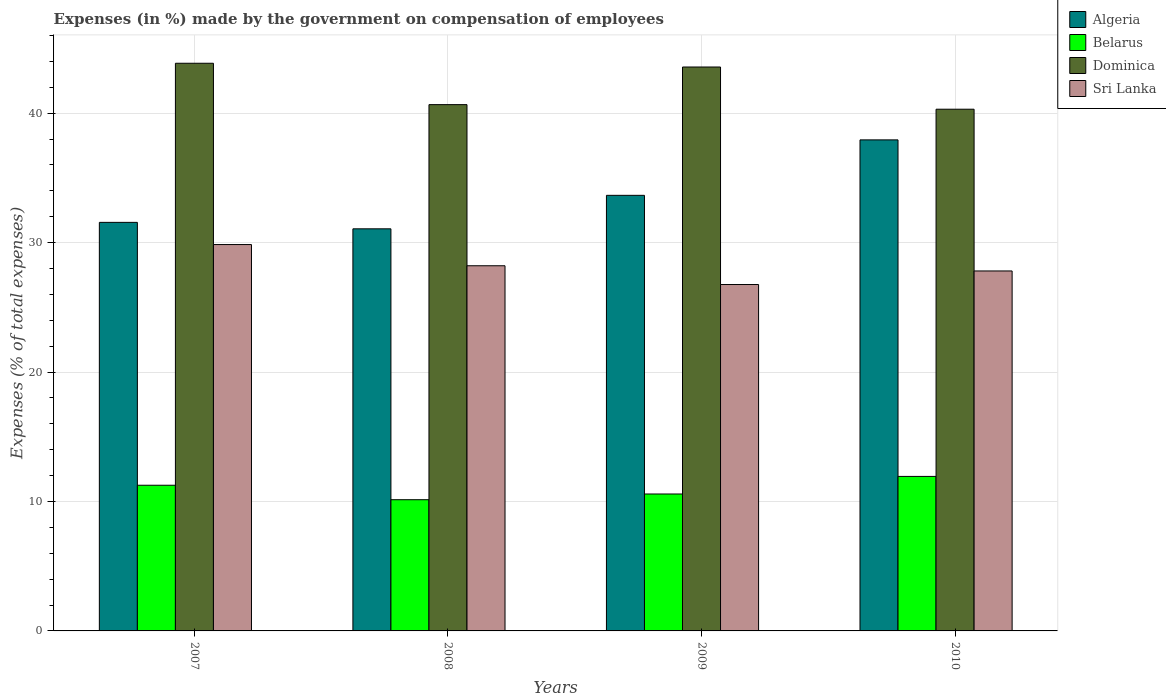How many different coloured bars are there?
Ensure brevity in your answer.  4. Are the number of bars per tick equal to the number of legend labels?
Provide a short and direct response. Yes. Are the number of bars on each tick of the X-axis equal?
Ensure brevity in your answer.  Yes. What is the percentage of expenses made by the government on compensation of employees in Sri Lanka in 2010?
Your response must be concise. 27.81. Across all years, what is the maximum percentage of expenses made by the government on compensation of employees in Dominica?
Your response must be concise. 43.86. Across all years, what is the minimum percentage of expenses made by the government on compensation of employees in Dominica?
Offer a terse response. 40.31. In which year was the percentage of expenses made by the government on compensation of employees in Dominica maximum?
Keep it short and to the point. 2007. In which year was the percentage of expenses made by the government on compensation of employees in Sri Lanka minimum?
Provide a succinct answer. 2009. What is the total percentage of expenses made by the government on compensation of employees in Belarus in the graph?
Provide a succinct answer. 43.91. What is the difference between the percentage of expenses made by the government on compensation of employees in Dominica in 2008 and that in 2009?
Offer a very short reply. -2.91. What is the difference between the percentage of expenses made by the government on compensation of employees in Belarus in 2010 and the percentage of expenses made by the government on compensation of employees in Dominica in 2009?
Offer a terse response. -31.63. What is the average percentage of expenses made by the government on compensation of employees in Dominica per year?
Provide a short and direct response. 42.1. In the year 2009, what is the difference between the percentage of expenses made by the government on compensation of employees in Belarus and percentage of expenses made by the government on compensation of employees in Dominica?
Provide a succinct answer. -32.99. What is the ratio of the percentage of expenses made by the government on compensation of employees in Sri Lanka in 2008 to that in 2010?
Make the answer very short. 1.01. What is the difference between the highest and the second highest percentage of expenses made by the government on compensation of employees in Algeria?
Your response must be concise. 4.28. What is the difference between the highest and the lowest percentage of expenses made by the government on compensation of employees in Sri Lanka?
Provide a short and direct response. 3.09. In how many years, is the percentage of expenses made by the government on compensation of employees in Algeria greater than the average percentage of expenses made by the government on compensation of employees in Algeria taken over all years?
Offer a very short reply. 2. Is it the case that in every year, the sum of the percentage of expenses made by the government on compensation of employees in Dominica and percentage of expenses made by the government on compensation of employees in Algeria is greater than the sum of percentage of expenses made by the government on compensation of employees in Belarus and percentage of expenses made by the government on compensation of employees in Sri Lanka?
Your answer should be compact. No. What does the 4th bar from the left in 2009 represents?
Make the answer very short. Sri Lanka. What does the 4th bar from the right in 2009 represents?
Keep it short and to the point. Algeria. Is it the case that in every year, the sum of the percentage of expenses made by the government on compensation of employees in Belarus and percentage of expenses made by the government on compensation of employees in Sri Lanka is greater than the percentage of expenses made by the government on compensation of employees in Dominica?
Ensure brevity in your answer.  No. How many bars are there?
Provide a short and direct response. 16. Are the values on the major ticks of Y-axis written in scientific E-notation?
Provide a short and direct response. No. Does the graph contain grids?
Ensure brevity in your answer.  Yes. How many legend labels are there?
Offer a terse response. 4. What is the title of the graph?
Keep it short and to the point. Expenses (in %) made by the government on compensation of employees. Does "United Arab Emirates" appear as one of the legend labels in the graph?
Offer a very short reply. No. What is the label or title of the X-axis?
Offer a terse response. Years. What is the label or title of the Y-axis?
Provide a short and direct response. Expenses (% of total expenses). What is the Expenses (% of total expenses) in Algeria in 2007?
Provide a succinct answer. 31.57. What is the Expenses (% of total expenses) in Belarus in 2007?
Keep it short and to the point. 11.26. What is the Expenses (% of total expenses) of Dominica in 2007?
Offer a terse response. 43.86. What is the Expenses (% of total expenses) in Sri Lanka in 2007?
Keep it short and to the point. 29.85. What is the Expenses (% of total expenses) in Algeria in 2008?
Offer a terse response. 31.07. What is the Expenses (% of total expenses) of Belarus in 2008?
Give a very brief answer. 10.14. What is the Expenses (% of total expenses) of Dominica in 2008?
Ensure brevity in your answer.  40.66. What is the Expenses (% of total expenses) of Sri Lanka in 2008?
Keep it short and to the point. 28.21. What is the Expenses (% of total expenses) in Algeria in 2009?
Your answer should be very brief. 33.66. What is the Expenses (% of total expenses) in Belarus in 2009?
Provide a short and direct response. 10.58. What is the Expenses (% of total expenses) of Dominica in 2009?
Make the answer very short. 43.57. What is the Expenses (% of total expenses) in Sri Lanka in 2009?
Your answer should be very brief. 26.76. What is the Expenses (% of total expenses) in Algeria in 2010?
Make the answer very short. 37.94. What is the Expenses (% of total expenses) in Belarus in 2010?
Your answer should be very brief. 11.94. What is the Expenses (% of total expenses) in Dominica in 2010?
Provide a succinct answer. 40.31. What is the Expenses (% of total expenses) of Sri Lanka in 2010?
Give a very brief answer. 27.81. Across all years, what is the maximum Expenses (% of total expenses) of Algeria?
Offer a very short reply. 37.94. Across all years, what is the maximum Expenses (% of total expenses) of Belarus?
Give a very brief answer. 11.94. Across all years, what is the maximum Expenses (% of total expenses) in Dominica?
Provide a succinct answer. 43.86. Across all years, what is the maximum Expenses (% of total expenses) in Sri Lanka?
Offer a terse response. 29.85. Across all years, what is the minimum Expenses (% of total expenses) in Algeria?
Offer a very short reply. 31.07. Across all years, what is the minimum Expenses (% of total expenses) of Belarus?
Make the answer very short. 10.14. Across all years, what is the minimum Expenses (% of total expenses) of Dominica?
Provide a short and direct response. 40.31. Across all years, what is the minimum Expenses (% of total expenses) in Sri Lanka?
Ensure brevity in your answer.  26.76. What is the total Expenses (% of total expenses) in Algeria in the graph?
Offer a very short reply. 134.23. What is the total Expenses (% of total expenses) in Belarus in the graph?
Your answer should be compact. 43.91. What is the total Expenses (% of total expenses) in Dominica in the graph?
Offer a terse response. 168.4. What is the total Expenses (% of total expenses) in Sri Lanka in the graph?
Offer a terse response. 112.64. What is the difference between the Expenses (% of total expenses) in Algeria in 2007 and that in 2008?
Your answer should be compact. 0.5. What is the difference between the Expenses (% of total expenses) in Belarus in 2007 and that in 2008?
Your answer should be very brief. 1.12. What is the difference between the Expenses (% of total expenses) in Dominica in 2007 and that in 2008?
Give a very brief answer. 3.2. What is the difference between the Expenses (% of total expenses) in Sri Lanka in 2007 and that in 2008?
Provide a succinct answer. 1.64. What is the difference between the Expenses (% of total expenses) of Algeria in 2007 and that in 2009?
Provide a succinct answer. -2.09. What is the difference between the Expenses (% of total expenses) of Belarus in 2007 and that in 2009?
Provide a short and direct response. 0.68. What is the difference between the Expenses (% of total expenses) in Dominica in 2007 and that in 2009?
Your response must be concise. 0.29. What is the difference between the Expenses (% of total expenses) of Sri Lanka in 2007 and that in 2009?
Offer a terse response. 3.09. What is the difference between the Expenses (% of total expenses) in Algeria in 2007 and that in 2010?
Offer a very short reply. -6.37. What is the difference between the Expenses (% of total expenses) of Belarus in 2007 and that in 2010?
Your answer should be very brief. -0.68. What is the difference between the Expenses (% of total expenses) in Dominica in 2007 and that in 2010?
Ensure brevity in your answer.  3.55. What is the difference between the Expenses (% of total expenses) in Sri Lanka in 2007 and that in 2010?
Offer a very short reply. 2.04. What is the difference between the Expenses (% of total expenses) of Algeria in 2008 and that in 2009?
Offer a terse response. -2.59. What is the difference between the Expenses (% of total expenses) of Belarus in 2008 and that in 2009?
Provide a succinct answer. -0.44. What is the difference between the Expenses (% of total expenses) of Dominica in 2008 and that in 2009?
Offer a very short reply. -2.91. What is the difference between the Expenses (% of total expenses) of Sri Lanka in 2008 and that in 2009?
Offer a terse response. 1.45. What is the difference between the Expenses (% of total expenses) of Algeria in 2008 and that in 2010?
Make the answer very short. -6.87. What is the difference between the Expenses (% of total expenses) in Belarus in 2008 and that in 2010?
Ensure brevity in your answer.  -1.8. What is the difference between the Expenses (% of total expenses) in Dominica in 2008 and that in 2010?
Make the answer very short. 0.35. What is the difference between the Expenses (% of total expenses) in Sri Lanka in 2008 and that in 2010?
Your answer should be compact. 0.4. What is the difference between the Expenses (% of total expenses) in Algeria in 2009 and that in 2010?
Provide a short and direct response. -4.28. What is the difference between the Expenses (% of total expenses) in Belarus in 2009 and that in 2010?
Ensure brevity in your answer.  -1.36. What is the difference between the Expenses (% of total expenses) of Dominica in 2009 and that in 2010?
Make the answer very short. 3.26. What is the difference between the Expenses (% of total expenses) in Sri Lanka in 2009 and that in 2010?
Your answer should be very brief. -1.05. What is the difference between the Expenses (% of total expenses) of Algeria in 2007 and the Expenses (% of total expenses) of Belarus in 2008?
Keep it short and to the point. 21.43. What is the difference between the Expenses (% of total expenses) of Algeria in 2007 and the Expenses (% of total expenses) of Dominica in 2008?
Offer a very short reply. -9.1. What is the difference between the Expenses (% of total expenses) of Algeria in 2007 and the Expenses (% of total expenses) of Sri Lanka in 2008?
Keep it short and to the point. 3.35. What is the difference between the Expenses (% of total expenses) of Belarus in 2007 and the Expenses (% of total expenses) of Dominica in 2008?
Your answer should be very brief. -29.41. What is the difference between the Expenses (% of total expenses) in Belarus in 2007 and the Expenses (% of total expenses) in Sri Lanka in 2008?
Ensure brevity in your answer.  -16.96. What is the difference between the Expenses (% of total expenses) of Dominica in 2007 and the Expenses (% of total expenses) of Sri Lanka in 2008?
Your answer should be very brief. 15.65. What is the difference between the Expenses (% of total expenses) of Algeria in 2007 and the Expenses (% of total expenses) of Belarus in 2009?
Provide a succinct answer. 20.99. What is the difference between the Expenses (% of total expenses) in Algeria in 2007 and the Expenses (% of total expenses) in Dominica in 2009?
Offer a very short reply. -12. What is the difference between the Expenses (% of total expenses) of Algeria in 2007 and the Expenses (% of total expenses) of Sri Lanka in 2009?
Offer a terse response. 4.8. What is the difference between the Expenses (% of total expenses) in Belarus in 2007 and the Expenses (% of total expenses) in Dominica in 2009?
Offer a terse response. -32.31. What is the difference between the Expenses (% of total expenses) of Belarus in 2007 and the Expenses (% of total expenses) of Sri Lanka in 2009?
Provide a succinct answer. -15.51. What is the difference between the Expenses (% of total expenses) in Dominica in 2007 and the Expenses (% of total expenses) in Sri Lanka in 2009?
Ensure brevity in your answer.  17.1. What is the difference between the Expenses (% of total expenses) in Algeria in 2007 and the Expenses (% of total expenses) in Belarus in 2010?
Your answer should be very brief. 19.63. What is the difference between the Expenses (% of total expenses) of Algeria in 2007 and the Expenses (% of total expenses) of Dominica in 2010?
Offer a very short reply. -8.74. What is the difference between the Expenses (% of total expenses) in Algeria in 2007 and the Expenses (% of total expenses) in Sri Lanka in 2010?
Give a very brief answer. 3.76. What is the difference between the Expenses (% of total expenses) in Belarus in 2007 and the Expenses (% of total expenses) in Dominica in 2010?
Your answer should be compact. -29.05. What is the difference between the Expenses (% of total expenses) of Belarus in 2007 and the Expenses (% of total expenses) of Sri Lanka in 2010?
Your answer should be compact. -16.56. What is the difference between the Expenses (% of total expenses) in Dominica in 2007 and the Expenses (% of total expenses) in Sri Lanka in 2010?
Offer a very short reply. 16.05. What is the difference between the Expenses (% of total expenses) in Algeria in 2008 and the Expenses (% of total expenses) in Belarus in 2009?
Your response must be concise. 20.49. What is the difference between the Expenses (% of total expenses) in Algeria in 2008 and the Expenses (% of total expenses) in Dominica in 2009?
Your answer should be compact. -12.5. What is the difference between the Expenses (% of total expenses) in Algeria in 2008 and the Expenses (% of total expenses) in Sri Lanka in 2009?
Make the answer very short. 4.3. What is the difference between the Expenses (% of total expenses) of Belarus in 2008 and the Expenses (% of total expenses) of Dominica in 2009?
Provide a succinct answer. -33.43. What is the difference between the Expenses (% of total expenses) in Belarus in 2008 and the Expenses (% of total expenses) in Sri Lanka in 2009?
Your answer should be very brief. -16.63. What is the difference between the Expenses (% of total expenses) in Dominica in 2008 and the Expenses (% of total expenses) in Sri Lanka in 2009?
Provide a succinct answer. 13.9. What is the difference between the Expenses (% of total expenses) of Algeria in 2008 and the Expenses (% of total expenses) of Belarus in 2010?
Your response must be concise. 19.13. What is the difference between the Expenses (% of total expenses) in Algeria in 2008 and the Expenses (% of total expenses) in Dominica in 2010?
Offer a terse response. -9.24. What is the difference between the Expenses (% of total expenses) of Algeria in 2008 and the Expenses (% of total expenses) of Sri Lanka in 2010?
Offer a very short reply. 3.26. What is the difference between the Expenses (% of total expenses) of Belarus in 2008 and the Expenses (% of total expenses) of Dominica in 2010?
Make the answer very short. -30.17. What is the difference between the Expenses (% of total expenses) of Belarus in 2008 and the Expenses (% of total expenses) of Sri Lanka in 2010?
Provide a succinct answer. -17.67. What is the difference between the Expenses (% of total expenses) in Dominica in 2008 and the Expenses (% of total expenses) in Sri Lanka in 2010?
Keep it short and to the point. 12.85. What is the difference between the Expenses (% of total expenses) of Algeria in 2009 and the Expenses (% of total expenses) of Belarus in 2010?
Keep it short and to the point. 21.72. What is the difference between the Expenses (% of total expenses) of Algeria in 2009 and the Expenses (% of total expenses) of Dominica in 2010?
Your answer should be very brief. -6.65. What is the difference between the Expenses (% of total expenses) of Algeria in 2009 and the Expenses (% of total expenses) of Sri Lanka in 2010?
Provide a succinct answer. 5.84. What is the difference between the Expenses (% of total expenses) in Belarus in 2009 and the Expenses (% of total expenses) in Dominica in 2010?
Keep it short and to the point. -29.73. What is the difference between the Expenses (% of total expenses) of Belarus in 2009 and the Expenses (% of total expenses) of Sri Lanka in 2010?
Keep it short and to the point. -17.23. What is the difference between the Expenses (% of total expenses) in Dominica in 2009 and the Expenses (% of total expenses) in Sri Lanka in 2010?
Keep it short and to the point. 15.76. What is the average Expenses (% of total expenses) of Algeria per year?
Your answer should be compact. 33.56. What is the average Expenses (% of total expenses) of Belarus per year?
Provide a succinct answer. 10.98. What is the average Expenses (% of total expenses) in Dominica per year?
Keep it short and to the point. 42.1. What is the average Expenses (% of total expenses) in Sri Lanka per year?
Make the answer very short. 28.16. In the year 2007, what is the difference between the Expenses (% of total expenses) of Algeria and Expenses (% of total expenses) of Belarus?
Your response must be concise. 20.31. In the year 2007, what is the difference between the Expenses (% of total expenses) of Algeria and Expenses (% of total expenses) of Dominica?
Your response must be concise. -12.29. In the year 2007, what is the difference between the Expenses (% of total expenses) of Algeria and Expenses (% of total expenses) of Sri Lanka?
Make the answer very short. 1.71. In the year 2007, what is the difference between the Expenses (% of total expenses) of Belarus and Expenses (% of total expenses) of Dominica?
Give a very brief answer. -32.6. In the year 2007, what is the difference between the Expenses (% of total expenses) of Belarus and Expenses (% of total expenses) of Sri Lanka?
Your answer should be very brief. -18.6. In the year 2007, what is the difference between the Expenses (% of total expenses) of Dominica and Expenses (% of total expenses) of Sri Lanka?
Your answer should be very brief. 14.01. In the year 2008, what is the difference between the Expenses (% of total expenses) in Algeria and Expenses (% of total expenses) in Belarus?
Provide a short and direct response. 20.93. In the year 2008, what is the difference between the Expenses (% of total expenses) of Algeria and Expenses (% of total expenses) of Dominica?
Give a very brief answer. -9.6. In the year 2008, what is the difference between the Expenses (% of total expenses) in Algeria and Expenses (% of total expenses) in Sri Lanka?
Your answer should be compact. 2.85. In the year 2008, what is the difference between the Expenses (% of total expenses) in Belarus and Expenses (% of total expenses) in Dominica?
Your answer should be very brief. -30.53. In the year 2008, what is the difference between the Expenses (% of total expenses) in Belarus and Expenses (% of total expenses) in Sri Lanka?
Give a very brief answer. -18.08. In the year 2008, what is the difference between the Expenses (% of total expenses) in Dominica and Expenses (% of total expenses) in Sri Lanka?
Ensure brevity in your answer.  12.45. In the year 2009, what is the difference between the Expenses (% of total expenses) of Algeria and Expenses (% of total expenses) of Belarus?
Provide a succinct answer. 23.08. In the year 2009, what is the difference between the Expenses (% of total expenses) of Algeria and Expenses (% of total expenses) of Dominica?
Ensure brevity in your answer.  -9.92. In the year 2009, what is the difference between the Expenses (% of total expenses) of Algeria and Expenses (% of total expenses) of Sri Lanka?
Offer a very short reply. 6.89. In the year 2009, what is the difference between the Expenses (% of total expenses) in Belarus and Expenses (% of total expenses) in Dominica?
Offer a very short reply. -32.99. In the year 2009, what is the difference between the Expenses (% of total expenses) in Belarus and Expenses (% of total expenses) in Sri Lanka?
Ensure brevity in your answer.  -16.18. In the year 2009, what is the difference between the Expenses (% of total expenses) in Dominica and Expenses (% of total expenses) in Sri Lanka?
Your answer should be compact. 16.81. In the year 2010, what is the difference between the Expenses (% of total expenses) in Algeria and Expenses (% of total expenses) in Belarus?
Offer a very short reply. 26. In the year 2010, what is the difference between the Expenses (% of total expenses) of Algeria and Expenses (% of total expenses) of Dominica?
Offer a terse response. -2.37. In the year 2010, what is the difference between the Expenses (% of total expenses) in Algeria and Expenses (% of total expenses) in Sri Lanka?
Your response must be concise. 10.13. In the year 2010, what is the difference between the Expenses (% of total expenses) in Belarus and Expenses (% of total expenses) in Dominica?
Keep it short and to the point. -28.37. In the year 2010, what is the difference between the Expenses (% of total expenses) in Belarus and Expenses (% of total expenses) in Sri Lanka?
Offer a very short reply. -15.87. In the year 2010, what is the difference between the Expenses (% of total expenses) in Dominica and Expenses (% of total expenses) in Sri Lanka?
Provide a succinct answer. 12.5. What is the ratio of the Expenses (% of total expenses) of Algeria in 2007 to that in 2008?
Make the answer very short. 1.02. What is the ratio of the Expenses (% of total expenses) in Belarus in 2007 to that in 2008?
Provide a short and direct response. 1.11. What is the ratio of the Expenses (% of total expenses) of Dominica in 2007 to that in 2008?
Ensure brevity in your answer.  1.08. What is the ratio of the Expenses (% of total expenses) in Sri Lanka in 2007 to that in 2008?
Provide a succinct answer. 1.06. What is the ratio of the Expenses (% of total expenses) in Algeria in 2007 to that in 2009?
Keep it short and to the point. 0.94. What is the ratio of the Expenses (% of total expenses) of Belarus in 2007 to that in 2009?
Your answer should be compact. 1.06. What is the ratio of the Expenses (% of total expenses) of Dominica in 2007 to that in 2009?
Your answer should be compact. 1.01. What is the ratio of the Expenses (% of total expenses) of Sri Lanka in 2007 to that in 2009?
Make the answer very short. 1.12. What is the ratio of the Expenses (% of total expenses) in Algeria in 2007 to that in 2010?
Keep it short and to the point. 0.83. What is the ratio of the Expenses (% of total expenses) of Belarus in 2007 to that in 2010?
Give a very brief answer. 0.94. What is the ratio of the Expenses (% of total expenses) of Dominica in 2007 to that in 2010?
Provide a succinct answer. 1.09. What is the ratio of the Expenses (% of total expenses) of Sri Lanka in 2007 to that in 2010?
Provide a short and direct response. 1.07. What is the ratio of the Expenses (% of total expenses) in Algeria in 2008 to that in 2009?
Provide a short and direct response. 0.92. What is the ratio of the Expenses (% of total expenses) of Belarus in 2008 to that in 2009?
Your response must be concise. 0.96. What is the ratio of the Expenses (% of total expenses) in Sri Lanka in 2008 to that in 2009?
Your answer should be compact. 1.05. What is the ratio of the Expenses (% of total expenses) in Algeria in 2008 to that in 2010?
Your answer should be very brief. 0.82. What is the ratio of the Expenses (% of total expenses) of Belarus in 2008 to that in 2010?
Provide a succinct answer. 0.85. What is the ratio of the Expenses (% of total expenses) of Dominica in 2008 to that in 2010?
Your answer should be very brief. 1.01. What is the ratio of the Expenses (% of total expenses) in Sri Lanka in 2008 to that in 2010?
Offer a very short reply. 1.01. What is the ratio of the Expenses (% of total expenses) of Algeria in 2009 to that in 2010?
Provide a short and direct response. 0.89. What is the ratio of the Expenses (% of total expenses) of Belarus in 2009 to that in 2010?
Offer a terse response. 0.89. What is the ratio of the Expenses (% of total expenses) in Dominica in 2009 to that in 2010?
Make the answer very short. 1.08. What is the ratio of the Expenses (% of total expenses) of Sri Lanka in 2009 to that in 2010?
Provide a succinct answer. 0.96. What is the difference between the highest and the second highest Expenses (% of total expenses) in Algeria?
Keep it short and to the point. 4.28. What is the difference between the highest and the second highest Expenses (% of total expenses) in Belarus?
Give a very brief answer. 0.68. What is the difference between the highest and the second highest Expenses (% of total expenses) in Dominica?
Your answer should be compact. 0.29. What is the difference between the highest and the second highest Expenses (% of total expenses) in Sri Lanka?
Your answer should be very brief. 1.64. What is the difference between the highest and the lowest Expenses (% of total expenses) in Algeria?
Make the answer very short. 6.87. What is the difference between the highest and the lowest Expenses (% of total expenses) of Belarus?
Give a very brief answer. 1.8. What is the difference between the highest and the lowest Expenses (% of total expenses) in Dominica?
Ensure brevity in your answer.  3.55. What is the difference between the highest and the lowest Expenses (% of total expenses) of Sri Lanka?
Give a very brief answer. 3.09. 